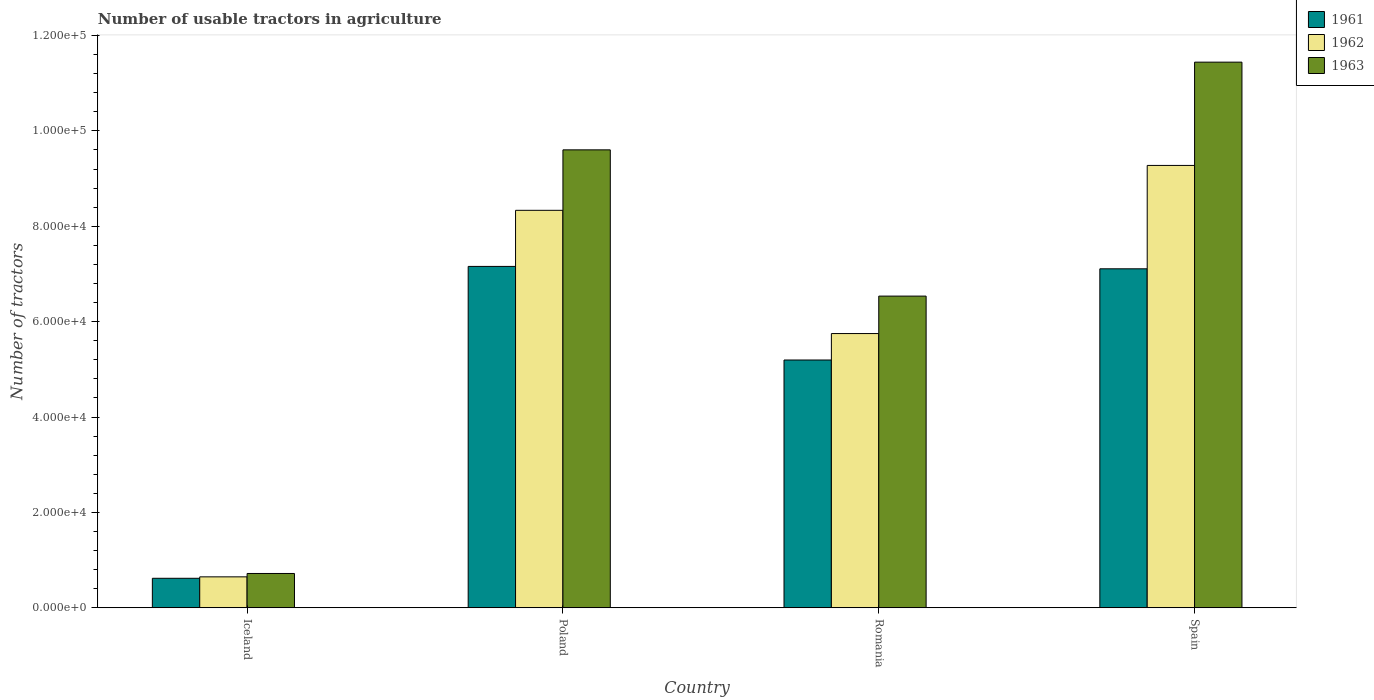How many different coloured bars are there?
Provide a short and direct response. 3. Are the number of bars on each tick of the X-axis equal?
Your answer should be very brief. Yes. How many bars are there on the 2nd tick from the right?
Your answer should be very brief. 3. In how many cases, is the number of bars for a given country not equal to the number of legend labels?
Keep it short and to the point. 0. What is the number of usable tractors in agriculture in 1961 in Poland?
Provide a short and direct response. 7.16e+04. Across all countries, what is the maximum number of usable tractors in agriculture in 1962?
Provide a succinct answer. 9.28e+04. Across all countries, what is the minimum number of usable tractors in agriculture in 1961?
Give a very brief answer. 6177. What is the total number of usable tractors in agriculture in 1962 in the graph?
Keep it short and to the point. 2.40e+05. What is the difference between the number of usable tractors in agriculture in 1963 in Iceland and that in Spain?
Provide a short and direct response. -1.07e+05. What is the difference between the number of usable tractors in agriculture in 1961 in Iceland and the number of usable tractors in agriculture in 1962 in Spain?
Your answer should be very brief. -8.66e+04. What is the average number of usable tractors in agriculture in 1962 per country?
Provide a short and direct response. 6.00e+04. What is the difference between the number of usable tractors in agriculture of/in 1963 and number of usable tractors in agriculture of/in 1962 in Romania?
Make the answer very short. 7851. What is the ratio of the number of usable tractors in agriculture in 1961 in Romania to that in Spain?
Offer a terse response. 0.73. Is the number of usable tractors in agriculture in 1961 in Iceland less than that in Spain?
Provide a succinct answer. Yes. What is the difference between the highest and the second highest number of usable tractors in agriculture in 1962?
Keep it short and to the point. 3.53e+04. What is the difference between the highest and the lowest number of usable tractors in agriculture in 1962?
Your answer should be compact. 8.63e+04. In how many countries, is the number of usable tractors in agriculture in 1963 greater than the average number of usable tractors in agriculture in 1963 taken over all countries?
Provide a succinct answer. 2. Is the sum of the number of usable tractors in agriculture in 1963 in Iceland and Poland greater than the maximum number of usable tractors in agriculture in 1961 across all countries?
Give a very brief answer. Yes. Is it the case that in every country, the sum of the number of usable tractors in agriculture in 1963 and number of usable tractors in agriculture in 1961 is greater than the number of usable tractors in agriculture in 1962?
Provide a short and direct response. Yes. What is the difference between two consecutive major ticks on the Y-axis?
Provide a succinct answer. 2.00e+04. Does the graph contain any zero values?
Offer a terse response. No. Does the graph contain grids?
Keep it short and to the point. No. How are the legend labels stacked?
Your response must be concise. Vertical. What is the title of the graph?
Provide a succinct answer. Number of usable tractors in agriculture. What is the label or title of the Y-axis?
Provide a short and direct response. Number of tractors. What is the Number of tractors in 1961 in Iceland?
Your answer should be compact. 6177. What is the Number of tractors of 1962 in Iceland?
Your response must be concise. 6479. What is the Number of tractors of 1963 in Iceland?
Offer a terse response. 7187. What is the Number of tractors in 1961 in Poland?
Make the answer very short. 7.16e+04. What is the Number of tractors in 1962 in Poland?
Give a very brief answer. 8.33e+04. What is the Number of tractors in 1963 in Poland?
Offer a very short reply. 9.60e+04. What is the Number of tractors in 1961 in Romania?
Ensure brevity in your answer.  5.20e+04. What is the Number of tractors of 1962 in Romania?
Your response must be concise. 5.75e+04. What is the Number of tractors in 1963 in Romania?
Offer a terse response. 6.54e+04. What is the Number of tractors of 1961 in Spain?
Your answer should be very brief. 7.11e+04. What is the Number of tractors in 1962 in Spain?
Keep it short and to the point. 9.28e+04. What is the Number of tractors of 1963 in Spain?
Your answer should be very brief. 1.14e+05. Across all countries, what is the maximum Number of tractors of 1961?
Provide a short and direct response. 7.16e+04. Across all countries, what is the maximum Number of tractors of 1962?
Provide a succinct answer. 9.28e+04. Across all countries, what is the maximum Number of tractors of 1963?
Keep it short and to the point. 1.14e+05. Across all countries, what is the minimum Number of tractors in 1961?
Offer a terse response. 6177. Across all countries, what is the minimum Number of tractors of 1962?
Your response must be concise. 6479. Across all countries, what is the minimum Number of tractors in 1963?
Offer a terse response. 7187. What is the total Number of tractors in 1961 in the graph?
Provide a succinct answer. 2.01e+05. What is the total Number of tractors in 1962 in the graph?
Give a very brief answer. 2.40e+05. What is the total Number of tractors in 1963 in the graph?
Offer a terse response. 2.83e+05. What is the difference between the Number of tractors in 1961 in Iceland and that in Poland?
Ensure brevity in your answer.  -6.54e+04. What is the difference between the Number of tractors in 1962 in Iceland and that in Poland?
Offer a terse response. -7.69e+04. What is the difference between the Number of tractors of 1963 in Iceland and that in Poland?
Your response must be concise. -8.88e+04. What is the difference between the Number of tractors of 1961 in Iceland and that in Romania?
Your answer should be compact. -4.58e+04. What is the difference between the Number of tractors of 1962 in Iceland and that in Romania?
Your answer should be compact. -5.10e+04. What is the difference between the Number of tractors of 1963 in Iceland and that in Romania?
Ensure brevity in your answer.  -5.82e+04. What is the difference between the Number of tractors of 1961 in Iceland and that in Spain?
Provide a short and direct response. -6.49e+04. What is the difference between the Number of tractors of 1962 in Iceland and that in Spain?
Make the answer very short. -8.63e+04. What is the difference between the Number of tractors of 1963 in Iceland and that in Spain?
Keep it short and to the point. -1.07e+05. What is the difference between the Number of tractors in 1961 in Poland and that in Romania?
Offer a terse response. 1.96e+04. What is the difference between the Number of tractors of 1962 in Poland and that in Romania?
Make the answer very short. 2.58e+04. What is the difference between the Number of tractors in 1963 in Poland and that in Romania?
Give a very brief answer. 3.07e+04. What is the difference between the Number of tractors in 1961 in Poland and that in Spain?
Offer a very short reply. 500. What is the difference between the Number of tractors in 1962 in Poland and that in Spain?
Provide a short and direct response. -9414. What is the difference between the Number of tractors in 1963 in Poland and that in Spain?
Give a very brief answer. -1.84e+04. What is the difference between the Number of tractors in 1961 in Romania and that in Spain?
Make the answer very short. -1.91e+04. What is the difference between the Number of tractors in 1962 in Romania and that in Spain?
Ensure brevity in your answer.  -3.53e+04. What is the difference between the Number of tractors of 1963 in Romania and that in Spain?
Make the answer very short. -4.91e+04. What is the difference between the Number of tractors of 1961 in Iceland and the Number of tractors of 1962 in Poland?
Your response must be concise. -7.72e+04. What is the difference between the Number of tractors in 1961 in Iceland and the Number of tractors in 1963 in Poland?
Your response must be concise. -8.98e+04. What is the difference between the Number of tractors in 1962 in Iceland and the Number of tractors in 1963 in Poland?
Your answer should be very brief. -8.95e+04. What is the difference between the Number of tractors of 1961 in Iceland and the Number of tractors of 1962 in Romania?
Your answer should be compact. -5.13e+04. What is the difference between the Number of tractors of 1961 in Iceland and the Number of tractors of 1963 in Romania?
Make the answer very short. -5.92e+04. What is the difference between the Number of tractors of 1962 in Iceland and the Number of tractors of 1963 in Romania?
Give a very brief answer. -5.89e+04. What is the difference between the Number of tractors in 1961 in Iceland and the Number of tractors in 1962 in Spain?
Make the answer very short. -8.66e+04. What is the difference between the Number of tractors of 1961 in Iceland and the Number of tractors of 1963 in Spain?
Your answer should be very brief. -1.08e+05. What is the difference between the Number of tractors in 1962 in Iceland and the Number of tractors in 1963 in Spain?
Keep it short and to the point. -1.08e+05. What is the difference between the Number of tractors in 1961 in Poland and the Number of tractors in 1962 in Romania?
Your response must be concise. 1.41e+04. What is the difference between the Number of tractors of 1961 in Poland and the Number of tractors of 1963 in Romania?
Offer a very short reply. 6226. What is the difference between the Number of tractors in 1962 in Poland and the Number of tractors in 1963 in Romania?
Your answer should be compact. 1.80e+04. What is the difference between the Number of tractors in 1961 in Poland and the Number of tractors in 1962 in Spain?
Offer a terse response. -2.12e+04. What is the difference between the Number of tractors in 1961 in Poland and the Number of tractors in 1963 in Spain?
Offer a very short reply. -4.28e+04. What is the difference between the Number of tractors of 1962 in Poland and the Number of tractors of 1963 in Spain?
Make the answer very short. -3.11e+04. What is the difference between the Number of tractors of 1961 in Romania and the Number of tractors of 1962 in Spain?
Give a very brief answer. -4.08e+04. What is the difference between the Number of tractors of 1961 in Romania and the Number of tractors of 1963 in Spain?
Provide a succinct answer. -6.25e+04. What is the difference between the Number of tractors in 1962 in Romania and the Number of tractors in 1963 in Spain?
Provide a succinct answer. -5.69e+04. What is the average Number of tractors of 1961 per country?
Your answer should be very brief. 5.02e+04. What is the average Number of tractors of 1962 per country?
Your answer should be compact. 6.00e+04. What is the average Number of tractors in 1963 per country?
Your answer should be very brief. 7.07e+04. What is the difference between the Number of tractors of 1961 and Number of tractors of 1962 in Iceland?
Offer a very short reply. -302. What is the difference between the Number of tractors in 1961 and Number of tractors in 1963 in Iceland?
Provide a short and direct response. -1010. What is the difference between the Number of tractors in 1962 and Number of tractors in 1963 in Iceland?
Provide a short and direct response. -708. What is the difference between the Number of tractors in 1961 and Number of tractors in 1962 in Poland?
Provide a short and direct response. -1.18e+04. What is the difference between the Number of tractors of 1961 and Number of tractors of 1963 in Poland?
Your response must be concise. -2.44e+04. What is the difference between the Number of tractors of 1962 and Number of tractors of 1963 in Poland?
Keep it short and to the point. -1.27e+04. What is the difference between the Number of tractors of 1961 and Number of tractors of 1962 in Romania?
Provide a short and direct response. -5548. What is the difference between the Number of tractors in 1961 and Number of tractors in 1963 in Romania?
Offer a terse response. -1.34e+04. What is the difference between the Number of tractors in 1962 and Number of tractors in 1963 in Romania?
Your answer should be very brief. -7851. What is the difference between the Number of tractors of 1961 and Number of tractors of 1962 in Spain?
Ensure brevity in your answer.  -2.17e+04. What is the difference between the Number of tractors in 1961 and Number of tractors in 1963 in Spain?
Your response must be concise. -4.33e+04. What is the difference between the Number of tractors of 1962 and Number of tractors of 1963 in Spain?
Keep it short and to the point. -2.17e+04. What is the ratio of the Number of tractors in 1961 in Iceland to that in Poland?
Your answer should be very brief. 0.09. What is the ratio of the Number of tractors in 1962 in Iceland to that in Poland?
Your answer should be very brief. 0.08. What is the ratio of the Number of tractors in 1963 in Iceland to that in Poland?
Offer a very short reply. 0.07. What is the ratio of the Number of tractors in 1961 in Iceland to that in Romania?
Offer a terse response. 0.12. What is the ratio of the Number of tractors of 1962 in Iceland to that in Romania?
Keep it short and to the point. 0.11. What is the ratio of the Number of tractors in 1963 in Iceland to that in Romania?
Provide a succinct answer. 0.11. What is the ratio of the Number of tractors of 1961 in Iceland to that in Spain?
Keep it short and to the point. 0.09. What is the ratio of the Number of tractors in 1962 in Iceland to that in Spain?
Offer a very short reply. 0.07. What is the ratio of the Number of tractors in 1963 in Iceland to that in Spain?
Make the answer very short. 0.06. What is the ratio of the Number of tractors of 1961 in Poland to that in Romania?
Provide a succinct answer. 1.38. What is the ratio of the Number of tractors of 1962 in Poland to that in Romania?
Your answer should be very brief. 1.45. What is the ratio of the Number of tractors in 1963 in Poland to that in Romania?
Provide a short and direct response. 1.47. What is the ratio of the Number of tractors of 1962 in Poland to that in Spain?
Your answer should be compact. 0.9. What is the ratio of the Number of tractors of 1963 in Poland to that in Spain?
Make the answer very short. 0.84. What is the ratio of the Number of tractors of 1961 in Romania to that in Spain?
Keep it short and to the point. 0.73. What is the ratio of the Number of tractors of 1962 in Romania to that in Spain?
Your answer should be very brief. 0.62. What is the ratio of the Number of tractors of 1963 in Romania to that in Spain?
Keep it short and to the point. 0.57. What is the difference between the highest and the second highest Number of tractors of 1962?
Your response must be concise. 9414. What is the difference between the highest and the second highest Number of tractors of 1963?
Your answer should be compact. 1.84e+04. What is the difference between the highest and the lowest Number of tractors of 1961?
Your answer should be compact. 6.54e+04. What is the difference between the highest and the lowest Number of tractors of 1962?
Provide a succinct answer. 8.63e+04. What is the difference between the highest and the lowest Number of tractors in 1963?
Offer a very short reply. 1.07e+05. 